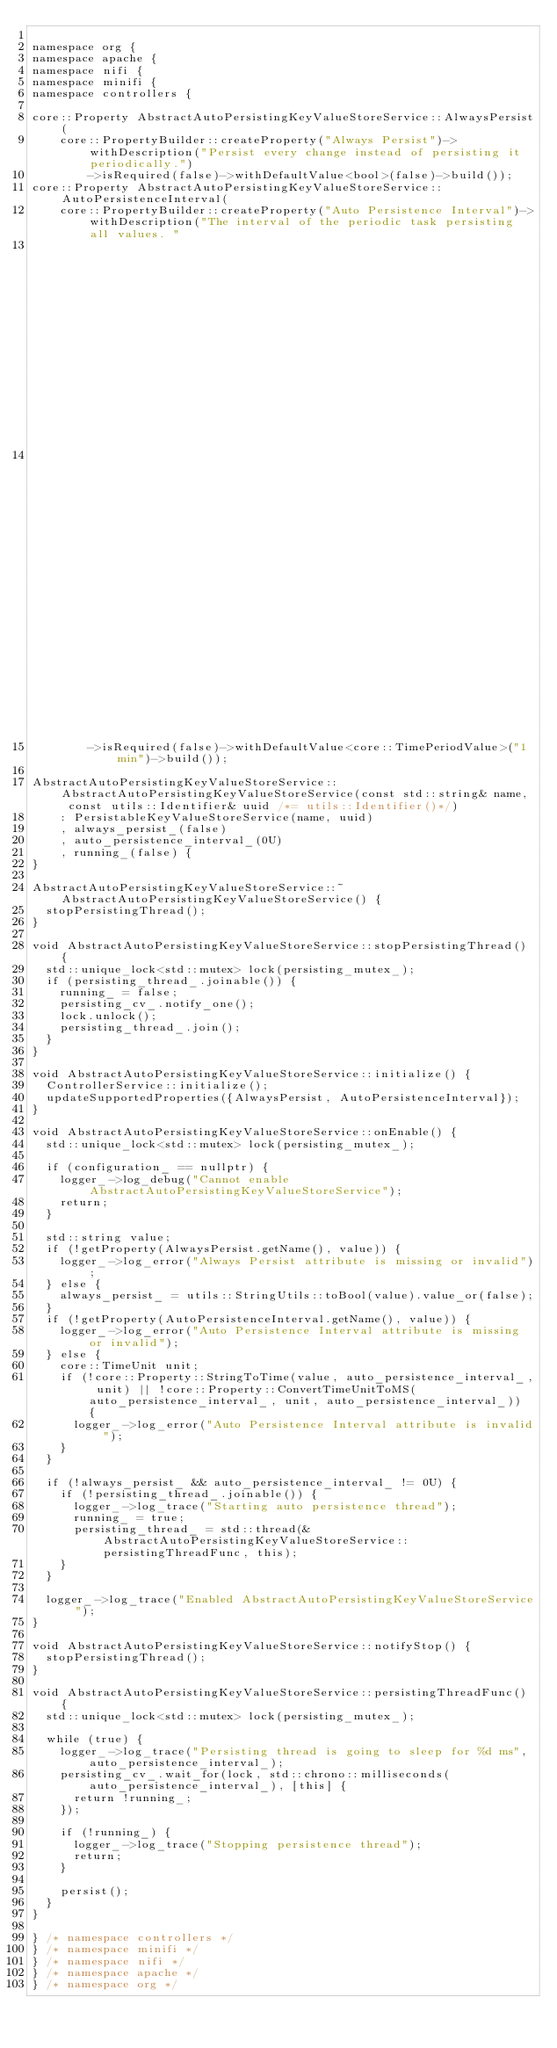<code> <loc_0><loc_0><loc_500><loc_500><_C++_>
namespace org {
namespace apache {
namespace nifi {
namespace minifi {
namespace controllers {

core::Property AbstractAutoPersistingKeyValueStoreService::AlwaysPersist(
    core::PropertyBuilder::createProperty("Always Persist")->withDescription("Persist every change instead of persisting it periodically.")
        ->isRequired(false)->withDefaultValue<bool>(false)->build());
core::Property AbstractAutoPersistingKeyValueStoreService::AutoPersistenceInterval(
    core::PropertyBuilder::createProperty("Auto Persistence Interval")->withDescription("The interval of the periodic task persisting all values. "
                                                                                        "Only used if Always Persist is false. "
                                                                                        "If set to 0 seconds, auto persistence will be disabled.")
        ->isRequired(false)->withDefaultValue<core::TimePeriodValue>("1 min")->build());

AbstractAutoPersistingKeyValueStoreService::AbstractAutoPersistingKeyValueStoreService(const std::string& name, const utils::Identifier& uuid /*= utils::Identifier()*/)
    : PersistableKeyValueStoreService(name, uuid)
    , always_persist_(false)
    , auto_persistence_interval_(0U)
    , running_(false) {
}

AbstractAutoPersistingKeyValueStoreService::~AbstractAutoPersistingKeyValueStoreService() {
  stopPersistingThread();
}

void AbstractAutoPersistingKeyValueStoreService::stopPersistingThread() {
  std::unique_lock<std::mutex> lock(persisting_mutex_);
  if (persisting_thread_.joinable()) {
    running_ = false;
    persisting_cv_.notify_one();
    lock.unlock();
    persisting_thread_.join();
  }
}

void AbstractAutoPersistingKeyValueStoreService::initialize() {
  ControllerService::initialize();
  updateSupportedProperties({AlwaysPersist, AutoPersistenceInterval});
}

void AbstractAutoPersistingKeyValueStoreService::onEnable() {
  std::unique_lock<std::mutex> lock(persisting_mutex_);

  if (configuration_ == nullptr) {
    logger_->log_debug("Cannot enable AbstractAutoPersistingKeyValueStoreService");
    return;
  }

  std::string value;
  if (!getProperty(AlwaysPersist.getName(), value)) {
    logger_->log_error("Always Persist attribute is missing or invalid");
  } else {
    always_persist_ = utils::StringUtils::toBool(value).value_or(false);
  }
  if (!getProperty(AutoPersistenceInterval.getName(), value)) {
    logger_->log_error("Auto Persistence Interval attribute is missing or invalid");
  } else {
    core::TimeUnit unit;
    if (!core::Property::StringToTime(value, auto_persistence_interval_, unit) || !core::Property::ConvertTimeUnitToMS(auto_persistence_interval_, unit, auto_persistence_interval_)) {
      logger_->log_error("Auto Persistence Interval attribute is invalid");
    }
  }

  if (!always_persist_ && auto_persistence_interval_ != 0U) {
    if (!persisting_thread_.joinable()) {
      logger_->log_trace("Starting auto persistence thread");
      running_ = true;
      persisting_thread_ = std::thread(&AbstractAutoPersistingKeyValueStoreService::persistingThreadFunc, this);
    }
  }

  logger_->log_trace("Enabled AbstractAutoPersistingKeyValueStoreService");
}

void AbstractAutoPersistingKeyValueStoreService::notifyStop() {
  stopPersistingThread();
}

void AbstractAutoPersistingKeyValueStoreService::persistingThreadFunc() {
  std::unique_lock<std::mutex> lock(persisting_mutex_);

  while (true) {
    logger_->log_trace("Persisting thread is going to sleep for %d ms", auto_persistence_interval_);
    persisting_cv_.wait_for(lock, std::chrono::milliseconds(auto_persistence_interval_), [this] {
      return !running_;
    });

    if (!running_) {
      logger_->log_trace("Stopping persistence thread");
      return;
    }

    persist();
  }
}

} /* namespace controllers */
} /* namespace minifi */
} /* namespace nifi */
} /* namespace apache */
} /* namespace org */
</code> 